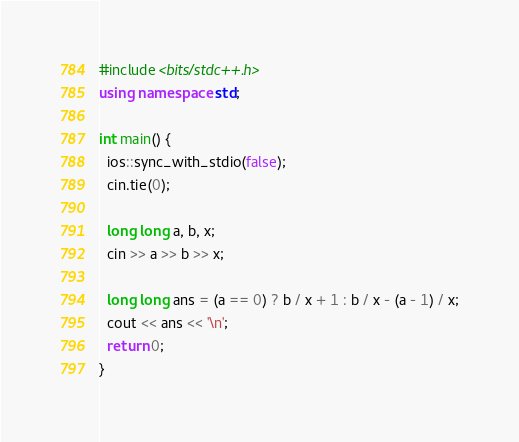Convert code to text. <code><loc_0><loc_0><loc_500><loc_500><_C++_>#include <bits/stdc++.h>
using namespace std;

int main() {
  ios::sync_with_stdio(false);
  cin.tie(0);

  long long a, b, x;
  cin >> a >> b >> x;
  
  long long ans = (a == 0) ? b / x + 1 : b / x - (a - 1) / x;
  cout << ans << '\n';
  return 0;
}</code> 